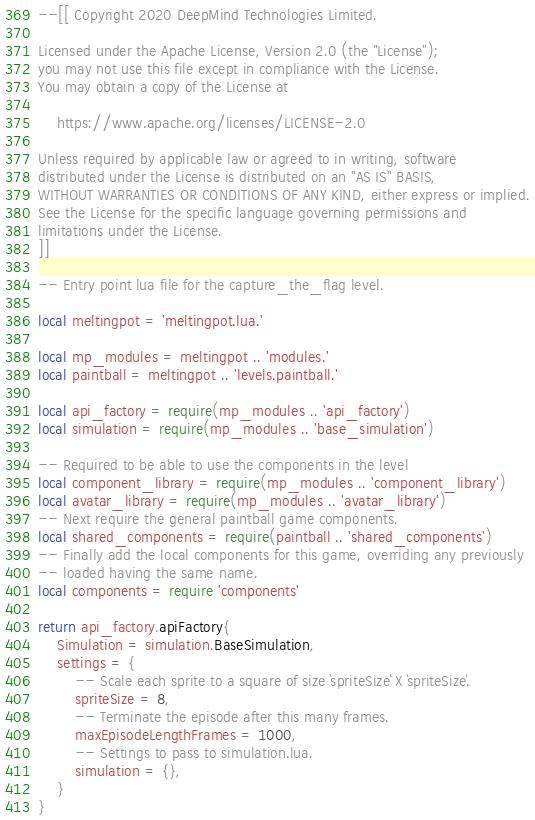<code> <loc_0><loc_0><loc_500><loc_500><_Lua_>--[[ Copyright 2020 DeepMind Technologies Limited.

Licensed under the Apache License, Version 2.0 (the "License");
you may not use this file except in compliance with the License.
You may obtain a copy of the License at

    https://www.apache.org/licenses/LICENSE-2.0

Unless required by applicable law or agreed to in writing, software
distributed under the License is distributed on an "AS IS" BASIS,
WITHOUT WARRANTIES OR CONDITIONS OF ANY KIND, either express or implied.
See the License for the specific language governing permissions and
limitations under the License.
]]

-- Entry point lua file for the capture_the_flag level.

local meltingpot = 'meltingpot.lua.'

local mp_modules = meltingpot .. 'modules.'
local paintball = meltingpot .. 'levels.paintball.'

local api_factory = require(mp_modules .. 'api_factory')
local simulation = require(mp_modules .. 'base_simulation')

-- Required to be able to use the components in the level
local component_library = require(mp_modules .. 'component_library')
local avatar_library = require(mp_modules .. 'avatar_library')
-- Next require the general paintball game components.
local shared_components = require(paintball .. 'shared_components')
-- Finally add the local components for this game, overriding any previously
-- loaded having the same name.
local components = require 'components'

return api_factory.apiFactory{
    Simulation = simulation.BaseSimulation,
    settings = {
        -- Scale each sprite to a square of size `spriteSize` X `spriteSize`.
        spriteSize = 8,
        -- Terminate the episode after this many frames.
        maxEpisodeLengthFrames = 1000,
        -- Settings to pass to simulation.lua.
        simulation = {},
    }
}
</code> 